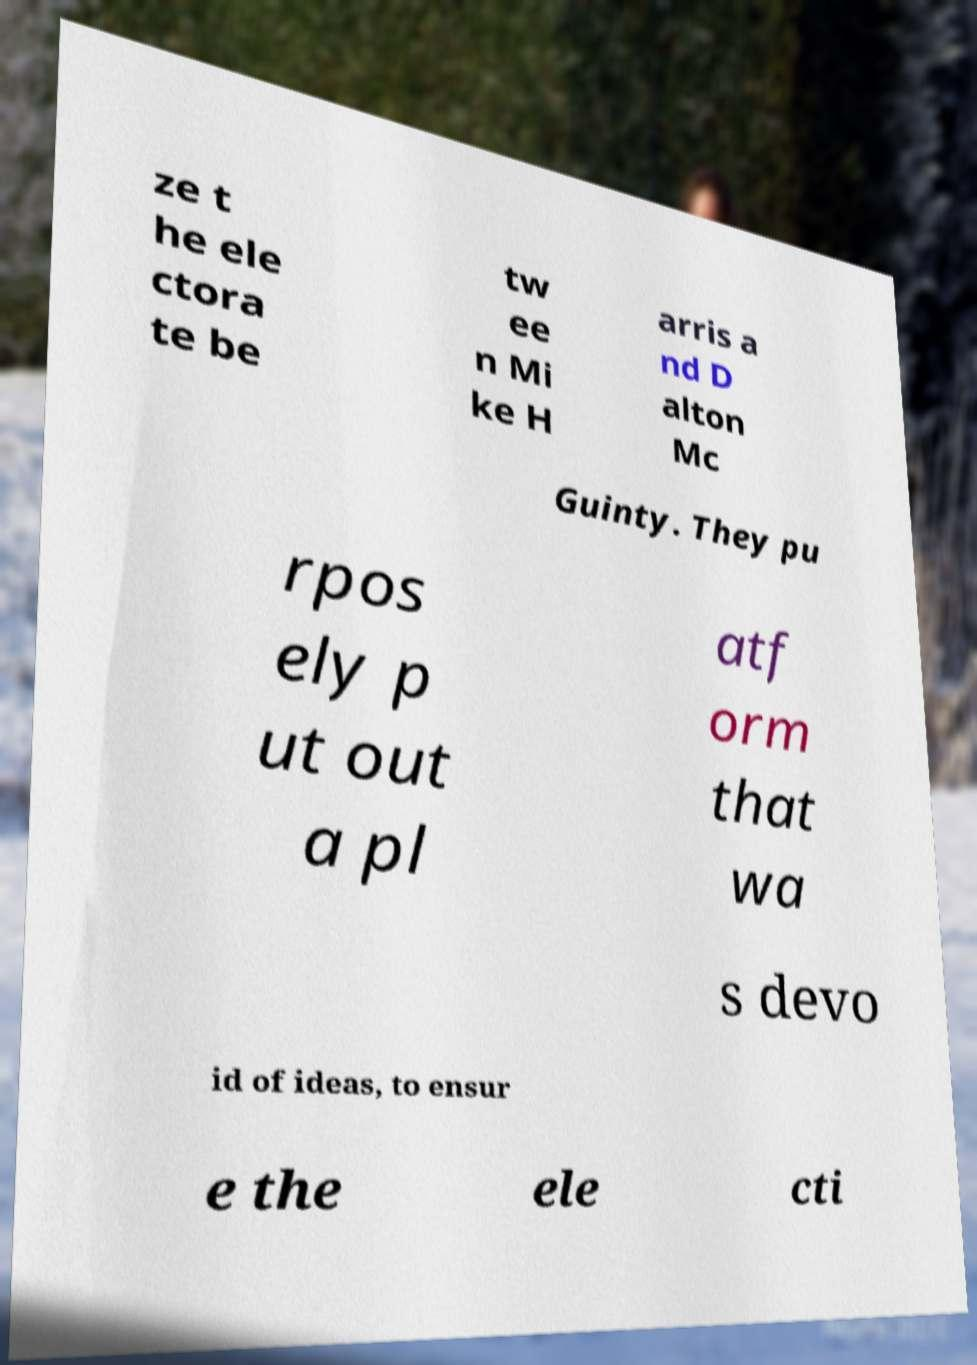There's text embedded in this image that I need extracted. Can you transcribe it verbatim? ze t he ele ctora te be tw ee n Mi ke H arris a nd D alton Mc Guinty. They pu rpos ely p ut out a pl atf orm that wa s devo id of ideas, to ensur e the ele cti 